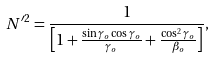Convert formula to latex. <formula><loc_0><loc_0><loc_500><loc_500>N ^ { \prime 2 } = \frac { 1 } { \left [ 1 + \frac { \sin \gamma _ { o } \cos \gamma _ { o } } { \gamma _ { o } } + \frac { \cos ^ { 2 } \gamma _ { o } } { \beta _ { o } } \right ] } ,</formula> 